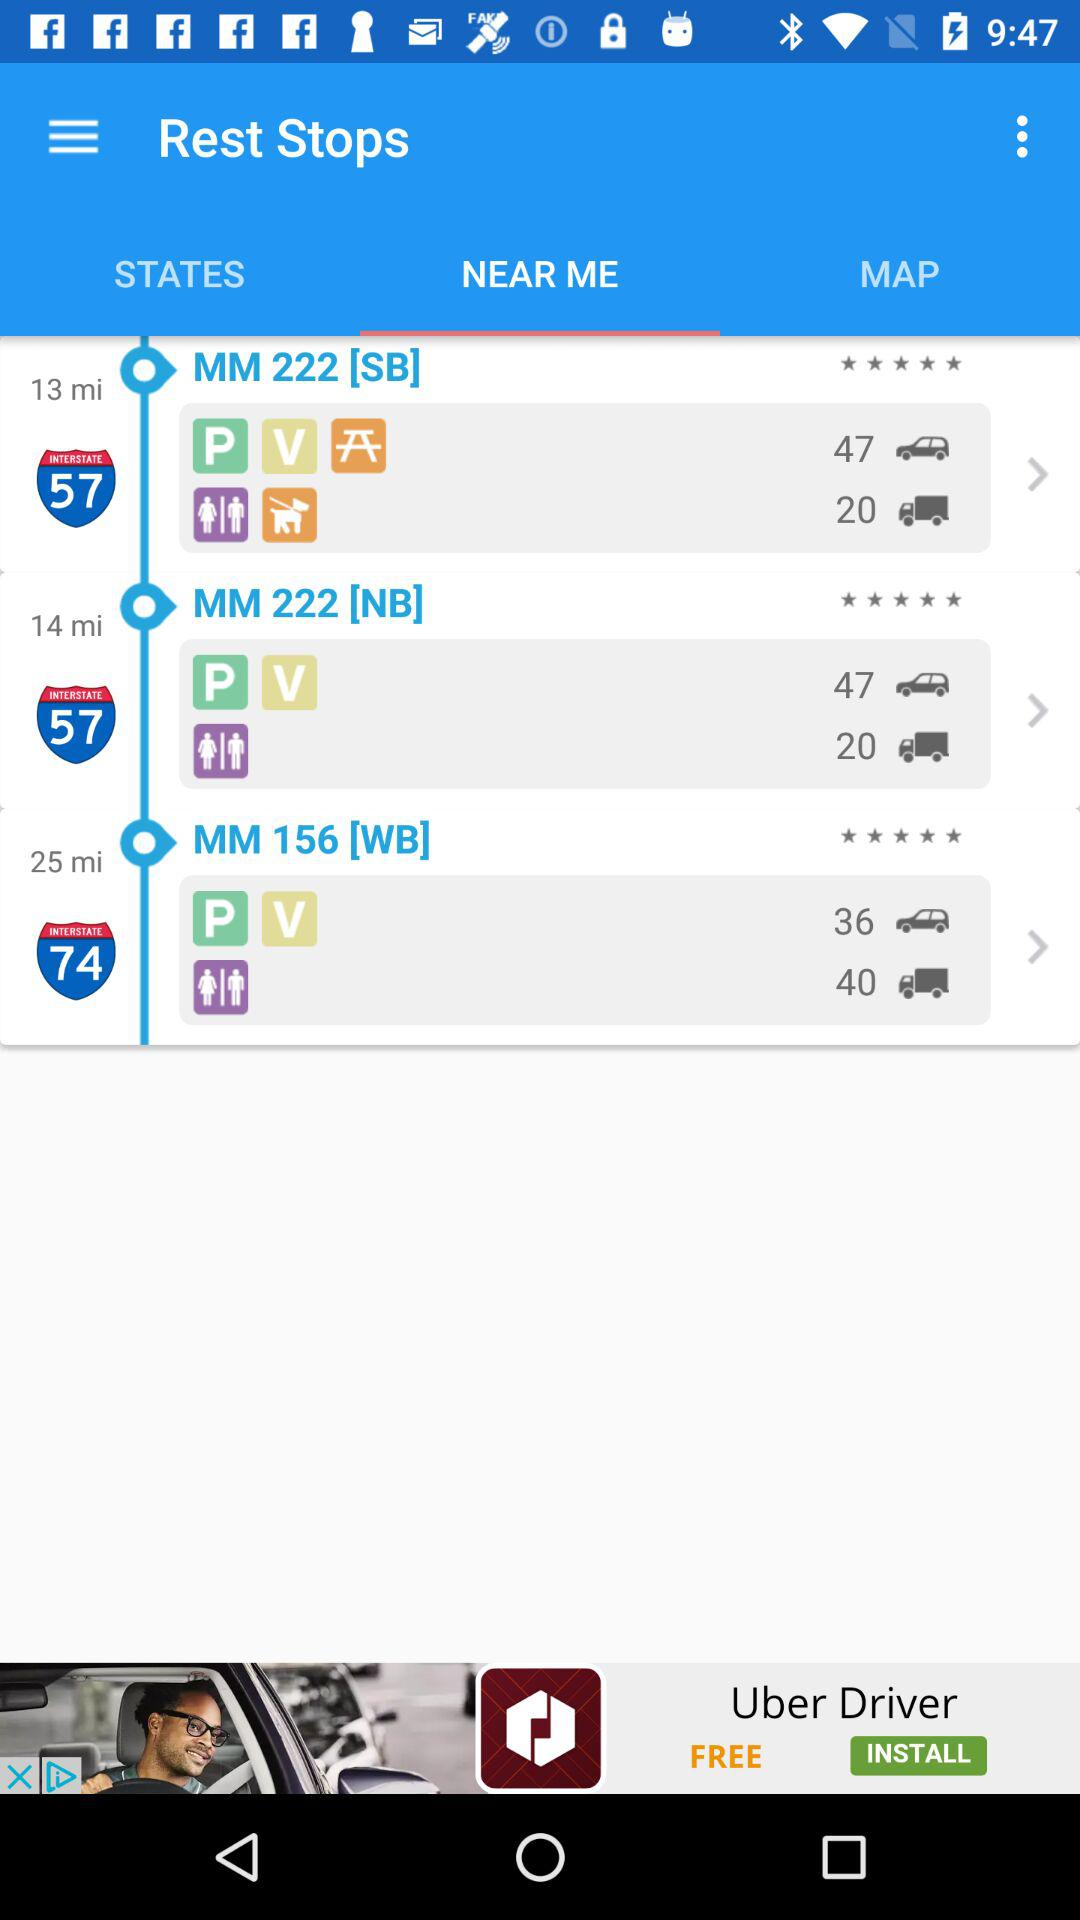How many stars does "MM 222 [NB]" have? "MM 222 [NB]" has 5 stars. 